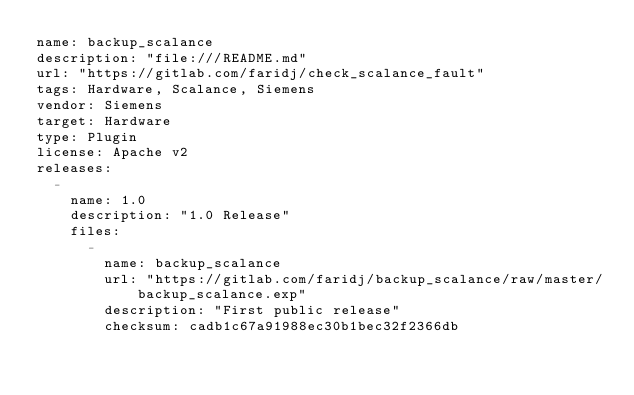Convert code to text. <code><loc_0><loc_0><loc_500><loc_500><_YAML_>name: backup_scalance
description: "file:///README.md"
url: "https://gitlab.com/faridj/check_scalance_fault"
tags: Hardware, Scalance, Siemens
vendor: Siemens
target: Hardware
type: Plugin
license: Apache v2
releases:
  -
    name: 1.0
    description: "1.0 Release"
    files:
      -
        name: backup_scalance
        url: "https://gitlab.com/faridj/backup_scalance/raw/master/backup_scalance.exp"
        description: "First public release"
        checksum: cadb1c67a91988ec30b1bec32f2366db 
</code> 